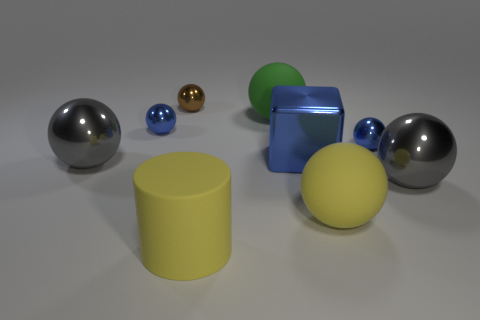There is a yellow sphere that is the same size as the cylinder; what is it made of?
Provide a succinct answer. Rubber. There is a gray shiny ball to the left of the brown metallic thing; is it the same size as the gray metallic object on the right side of the big blue object?
Your answer should be very brief. Yes. What number of things are either tiny metallic spheres or gray metallic spheres to the right of the tiny brown shiny ball?
Your answer should be very brief. 4. Are there any large green rubber objects that have the same shape as the brown metal thing?
Offer a very short reply. Yes. What is the size of the gray ball that is right of the blue object right of the blue block?
Offer a very short reply. Large. How many shiny things are cubes or large spheres?
Offer a terse response. 3. How many small objects are there?
Your answer should be compact. 3. Is the material of the blue sphere that is to the left of the brown object the same as the small object that is behind the big green rubber sphere?
Offer a terse response. Yes. There is another rubber thing that is the same shape as the green matte thing; what is its color?
Your response must be concise. Yellow. There is a small blue sphere left of the yellow rubber cylinder that is to the left of the big block; what is its material?
Keep it short and to the point. Metal. 